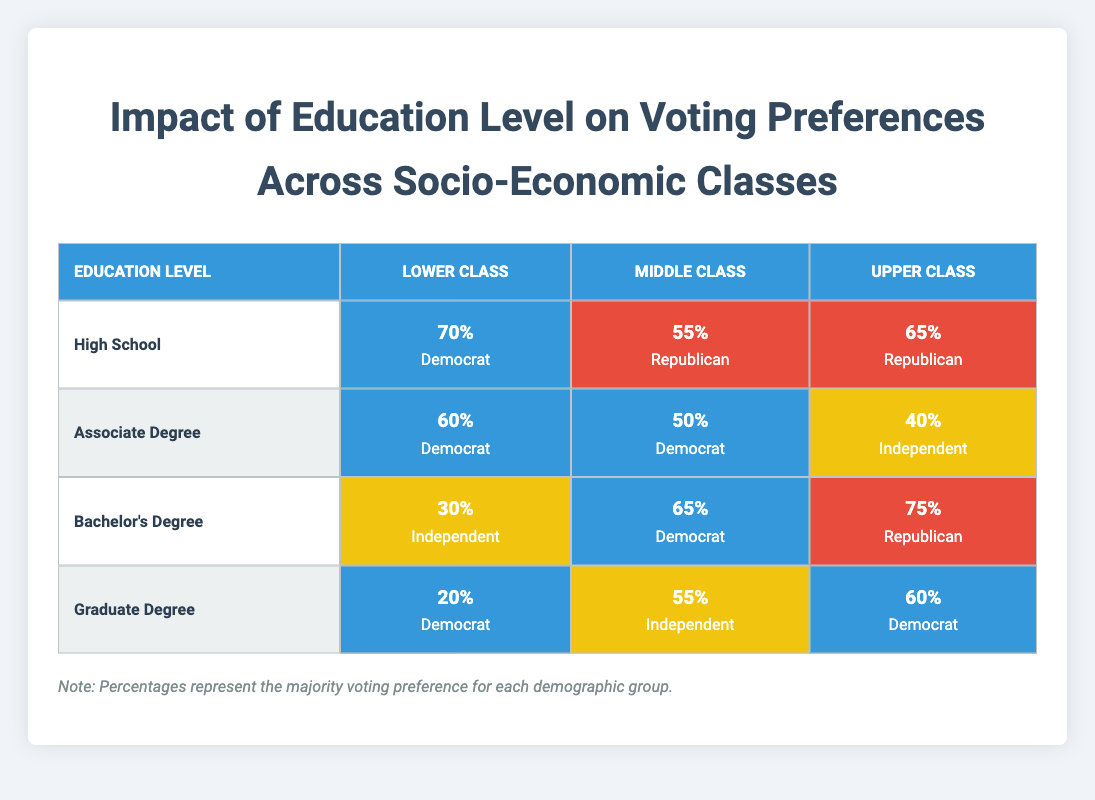What percentage of Lower Class voters with a Bachelor's Degree prefer Independents? Referring to the table, the section for Bachelor's Degree under Lower Class shows a voting preference for Independents at 30%.
Answer: 30% What is the voting preference of Upper Class voters with a Graduate Degree? Looking at the Graduate Degree row in the Upper Class column, the preference is for Democrat at 60%.
Answer: Democrat Does the percentage of Middle Class voters with a High School education preferring Republicans exceed 50%? In the High School row for Middle Class, the percentage is 55%, which is greater than 50%.
Answer: Yes What is the overall percentage gap in voting preferences for Democrats between Lower Class and Upper Class voters with an Associate Degree? The Lower Class votes Democrat at 60%, while the Upper Class votes Democrat at 40%, thus the gap is 60% - 40% = 20%.
Answer: 20% What is the predominant voting preference for Middle Class voters with an Associate Degree compared to Upper Class voters with the same education? The Middle Class has a preference for Democrat at 50%, whereas the Upper Class prefers Independent at 40%. Democrat is higher, so it is predominant.
Answer: Democrat Which education level is associated with the highest percentage of Republican preference for Upper Class voters? By reviewing the Upper Class row, the highest Republican preference is found in the Bachelor's Degree section at 75%.
Answer: Bachelor's Degree How many voters with a Graduate Degree from the Lower Class prefer Democrats compared to those from the Middle Class preferring Independents? Lower Class voters with a Graduate Degree prefer Democrats at 20%, while Middle Class voters prefer Independents at 55%. The comparison shows a clear preference for Independents in the Middle Class.
Answer: Middle Class prefers Independents Is the percentage of Independent voters with a Bachelor’s Degree from the Lower Class larger than the percentage of Graduate Degree voters from the Middle Class? The Lower Class with a Bachelor's Degree prefers Independents at 30% and the Middle Class with a Graduate Degree prefers Independents at 55%. Since 30% is less, the Lower Class does not exceed that percentage.
Answer: No 